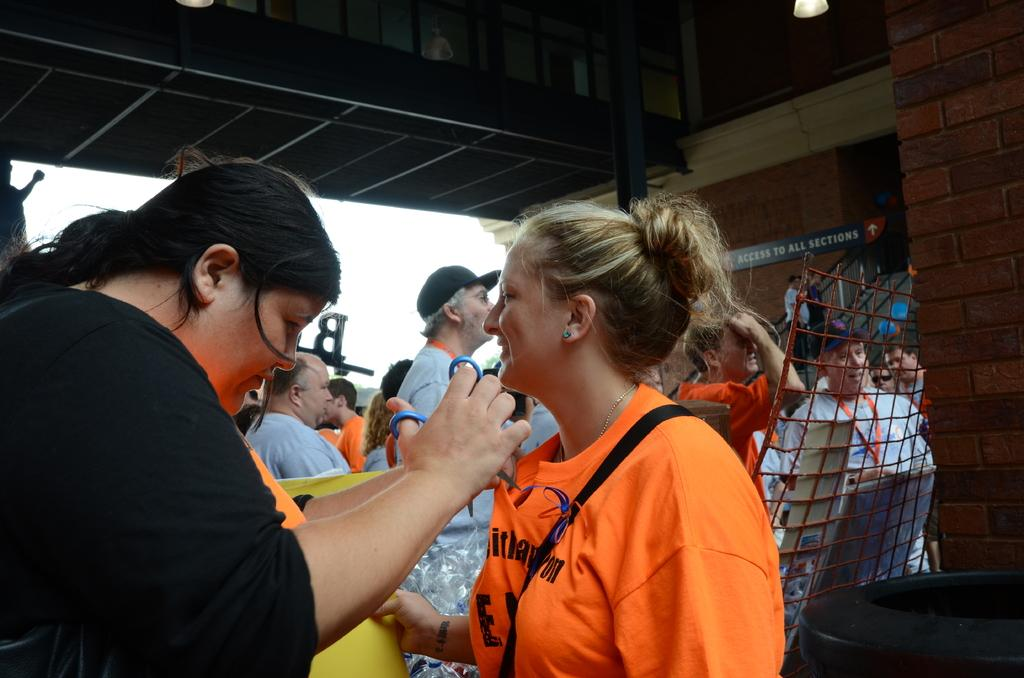How many people are present in the image? There are many people in the image. What are the people wearing? The people are wearing clothes. Can you describe any accessories visible in the image? There is an ear stud and a cap in the image. What objects can be seen in the image related to cutting or trimming? There is a scissor in the image. What type of structure is present in the image? There is a fence and a brick wall in the image. What type of lighting is present in the image? There is a light in the image. What type of sign or notice is present in the image? There is a board in the image. How many donkeys are visible in the image? There are no donkeys present in the image. What type of dolls can be seen playing with the cap in the image? There are no dolls present in the image, and the cap is worn by a person, not played with by dolls. 